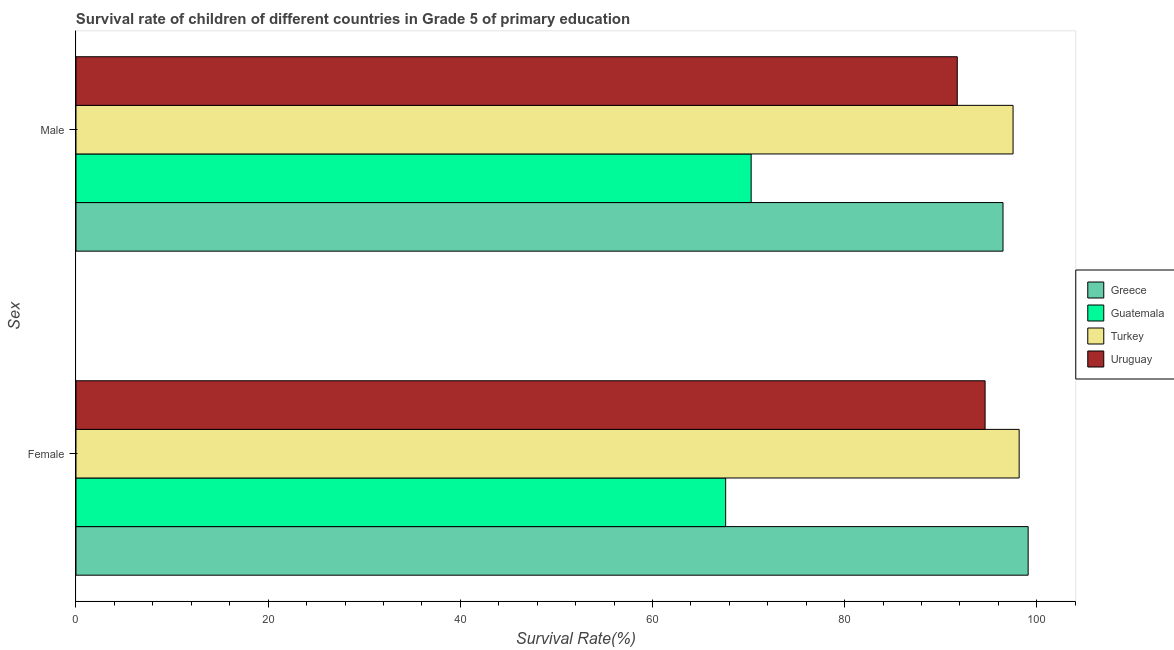Are the number of bars on each tick of the Y-axis equal?
Ensure brevity in your answer.  Yes. What is the label of the 1st group of bars from the top?
Your answer should be compact. Male. What is the survival rate of female students in primary education in Turkey?
Your answer should be compact. 98.17. Across all countries, what is the maximum survival rate of female students in primary education?
Offer a very short reply. 99.1. Across all countries, what is the minimum survival rate of male students in primary education?
Provide a succinct answer. 70.27. In which country was the survival rate of male students in primary education maximum?
Give a very brief answer. Turkey. In which country was the survival rate of female students in primary education minimum?
Provide a short and direct response. Guatemala. What is the total survival rate of male students in primary education in the graph?
Your answer should be very brief. 356.02. What is the difference between the survival rate of male students in primary education in Guatemala and that in Turkey?
Keep it short and to the point. -27.26. What is the difference between the survival rate of female students in primary education in Uruguay and the survival rate of male students in primary education in Turkey?
Ensure brevity in your answer.  -2.91. What is the average survival rate of female students in primary education per country?
Provide a short and direct response. 89.88. What is the difference between the survival rate of female students in primary education and survival rate of male students in primary education in Turkey?
Ensure brevity in your answer.  0.64. In how many countries, is the survival rate of female students in primary education greater than 52 %?
Provide a short and direct response. 4. What is the ratio of the survival rate of male students in primary education in Greece to that in Guatemala?
Your answer should be very brief. 1.37. Is the survival rate of male students in primary education in Greece less than that in Uruguay?
Your answer should be compact. No. In how many countries, is the survival rate of male students in primary education greater than the average survival rate of male students in primary education taken over all countries?
Keep it short and to the point. 3. What does the 1st bar from the top in Female represents?
Provide a short and direct response. Uruguay. What does the 4th bar from the bottom in Female represents?
Your answer should be compact. Uruguay. Are all the bars in the graph horizontal?
Make the answer very short. Yes. Are the values on the major ticks of X-axis written in scientific E-notation?
Offer a very short reply. No. Does the graph contain any zero values?
Provide a succinct answer. No. Where does the legend appear in the graph?
Give a very brief answer. Center right. How many legend labels are there?
Make the answer very short. 4. What is the title of the graph?
Make the answer very short. Survival rate of children of different countries in Grade 5 of primary education. Does "Antigua and Barbuda" appear as one of the legend labels in the graph?
Give a very brief answer. No. What is the label or title of the X-axis?
Give a very brief answer. Survival Rate(%). What is the label or title of the Y-axis?
Ensure brevity in your answer.  Sex. What is the Survival Rate(%) in Greece in Female?
Your response must be concise. 99.1. What is the Survival Rate(%) of Guatemala in Female?
Make the answer very short. 67.62. What is the Survival Rate(%) in Turkey in Female?
Your answer should be compact. 98.17. What is the Survival Rate(%) in Uruguay in Female?
Give a very brief answer. 94.62. What is the Survival Rate(%) of Greece in Male?
Provide a succinct answer. 96.49. What is the Survival Rate(%) in Guatemala in Male?
Give a very brief answer. 70.27. What is the Survival Rate(%) in Turkey in Male?
Your answer should be compact. 97.53. What is the Survival Rate(%) of Uruguay in Male?
Make the answer very short. 91.73. Across all Sex, what is the maximum Survival Rate(%) of Greece?
Your answer should be very brief. 99.1. Across all Sex, what is the maximum Survival Rate(%) in Guatemala?
Give a very brief answer. 70.27. Across all Sex, what is the maximum Survival Rate(%) in Turkey?
Give a very brief answer. 98.17. Across all Sex, what is the maximum Survival Rate(%) in Uruguay?
Your answer should be compact. 94.62. Across all Sex, what is the minimum Survival Rate(%) in Greece?
Provide a short and direct response. 96.49. Across all Sex, what is the minimum Survival Rate(%) of Guatemala?
Give a very brief answer. 67.62. Across all Sex, what is the minimum Survival Rate(%) in Turkey?
Your answer should be very brief. 97.53. Across all Sex, what is the minimum Survival Rate(%) of Uruguay?
Offer a terse response. 91.73. What is the total Survival Rate(%) in Greece in the graph?
Your answer should be very brief. 195.59. What is the total Survival Rate(%) of Guatemala in the graph?
Keep it short and to the point. 137.89. What is the total Survival Rate(%) of Turkey in the graph?
Ensure brevity in your answer.  195.7. What is the total Survival Rate(%) of Uruguay in the graph?
Offer a very short reply. 186.35. What is the difference between the Survival Rate(%) of Greece in Female and that in Male?
Give a very brief answer. 2.62. What is the difference between the Survival Rate(%) in Guatemala in Female and that in Male?
Offer a terse response. -2.65. What is the difference between the Survival Rate(%) in Turkey in Female and that in Male?
Your answer should be compact. 0.64. What is the difference between the Survival Rate(%) in Uruguay in Female and that in Male?
Provide a succinct answer. 2.9. What is the difference between the Survival Rate(%) of Greece in Female and the Survival Rate(%) of Guatemala in Male?
Offer a terse response. 28.83. What is the difference between the Survival Rate(%) in Greece in Female and the Survival Rate(%) in Turkey in Male?
Offer a very short reply. 1.57. What is the difference between the Survival Rate(%) in Greece in Female and the Survival Rate(%) in Uruguay in Male?
Your answer should be very brief. 7.38. What is the difference between the Survival Rate(%) of Guatemala in Female and the Survival Rate(%) of Turkey in Male?
Give a very brief answer. -29.91. What is the difference between the Survival Rate(%) in Guatemala in Female and the Survival Rate(%) in Uruguay in Male?
Your answer should be very brief. -24.11. What is the difference between the Survival Rate(%) of Turkey in Female and the Survival Rate(%) of Uruguay in Male?
Provide a succinct answer. 6.44. What is the average Survival Rate(%) in Greece per Sex?
Ensure brevity in your answer.  97.8. What is the average Survival Rate(%) in Guatemala per Sex?
Offer a very short reply. 68.95. What is the average Survival Rate(%) of Turkey per Sex?
Your answer should be very brief. 97.85. What is the average Survival Rate(%) of Uruguay per Sex?
Your answer should be compact. 93.17. What is the difference between the Survival Rate(%) of Greece and Survival Rate(%) of Guatemala in Female?
Make the answer very short. 31.48. What is the difference between the Survival Rate(%) of Greece and Survival Rate(%) of Turkey in Female?
Your answer should be very brief. 0.94. What is the difference between the Survival Rate(%) of Greece and Survival Rate(%) of Uruguay in Female?
Give a very brief answer. 4.48. What is the difference between the Survival Rate(%) in Guatemala and Survival Rate(%) in Turkey in Female?
Your response must be concise. -30.55. What is the difference between the Survival Rate(%) of Guatemala and Survival Rate(%) of Uruguay in Female?
Your answer should be very brief. -27. What is the difference between the Survival Rate(%) in Turkey and Survival Rate(%) in Uruguay in Female?
Offer a very short reply. 3.55. What is the difference between the Survival Rate(%) in Greece and Survival Rate(%) in Guatemala in Male?
Your response must be concise. 26.21. What is the difference between the Survival Rate(%) of Greece and Survival Rate(%) of Turkey in Male?
Provide a short and direct response. -1.05. What is the difference between the Survival Rate(%) of Greece and Survival Rate(%) of Uruguay in Male?
Offer a very short reply. 4.76. What is the difference between the Survival Rate(%) of Guatemala and Survival Rate(%) of Turkey in Male?
Your answer should be compact. -27.26. What is the difference between the Survival Rate(%) in Guatemala and Survival Rate(%) in Uruguay in Male?
Make the answer very short. -21.45. What is the difference between the Survival Rate(%) of Turkey and Survival Rate(%) of Uruguay in Male?
Your response must be concise. 5.81. What is the ratio of the Survival Rate(%) in Greece in Female to that in Male?
Offer a terse response. 1.03. What is the ratio of the Survival Rate(%) in Guatemala in Female to that in Male?
Give a very brief answer. 0.96. What is the ratio of the Survival Rate(%) in Turkey in Female to that in Male?
Your answer should be compact. 1.01. What is the ratio of the Survival Rate(%) in Uruguay in Female to that in Male?
Give a very brief answer. 1.03. What is the difference between the highest and the second highest Survival Rate(%) of Greece?
Provide a succinct answer. 2.62. What is the difference between the highest and the second highest Survival Rate(%) of Guatemala?
Your answer should be very brief. 2.65. What is the difference between the highest and the second highest Survival Rate(%) in Turkey?
Provide a short and direct response. 0.64. What is the difference between the highest and the second highest Survival Rate(%) in Uruguay?
Ensure brevity in your answer.  2.9. What is the difference between the highest and the lowest Survival Rate(%) in Greece?
Ensure brevity in your answer.  2.62. What is the difference between the highest and the lowest Survival Rate(%) of Guatemala?
Give a very brief answer. 2.65. What is the difference between the highest and the lowest Survival Rate(%) of Turkey?
Offer a very short reply. 0.64. What is the difference between the highest and the lowest Survival Rate(%) in Uruguay?
Offer a very short reply. 2.9. 